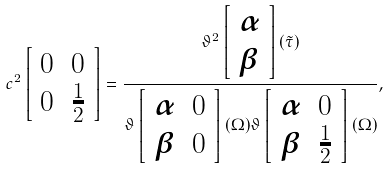Convert formula to latex. <formula><loc_0><loc_0><loc_500><loc_500>c ^ { 2 } \left [ \begin{array} { c c } 0 & 0 \\ 0 & \frac { 1 } { 2 } \\ \end{array} \right ] = \frac { \vartheta ^ { 2 } \left [ \begin{array} { c } \alpha \\ \beta \\ \end{array} \right ] ( { \tilde { \tau } } ) } { \vartheta \left [ \begin{array} { c c } \alpha & 0 \\ \beta & 0 \\ \end{array} \right ] ( \Omega ) \vartheta \left [ \begin{array} { c c } \alpha & 0 \\ \beta & \frac { 1 } { 2 } \\ \end{array} \right ] ( \Omega ) } ,</formula> 